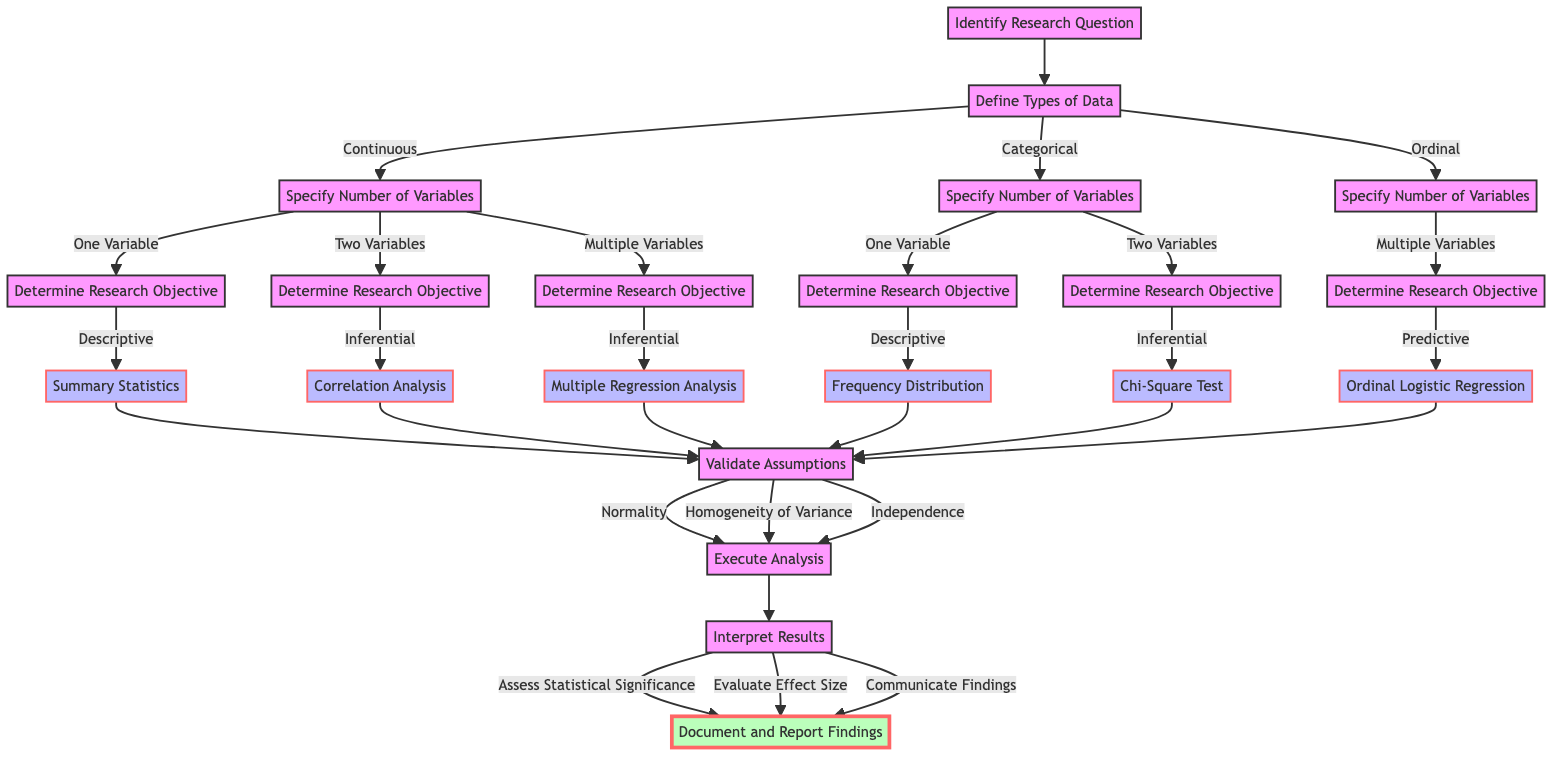What is the first step in the decision-making path? The diagram begins with the "Identify Research Question" node, indicating it is the starting point in the decision-making process for selecting a statistical analysis method.
Answer: Identify Research Question How many types of data are defined in the diagram? The diagram presents three types of data: Continuous, Categorical, and Ordinal, indicating that there are three specific categories to consider.
Answer: Three What method is selected for "Continuous and One Variable and Descriptive"? The condition results in the choice of "Summary Statistics (Mean, Median, SD)", which specifically caters to this scenario.
Answer: Summary Statistics (Mean, Median, SD) Which node follows "Validate Assumptions"? The next node after "Validate Assumptions" is "Execute Analysis", showing the progression from checking assumptions to executing the actual analysis.
Answer: Execute Analysis What is the significance of the edge that connects "Specify Number of Variables" to "Determine Research Objective"? This edge represents the decision point leading to selecting how many variables will be analyzed, impacting the objective, such as whether it is descriptive, inferential, or predictive.
Answer: It connects the number of variables to the research objective What assumptions must be validated according to the diagram? The diagram specifies three assumptions that must be validated: Normality, Homogeneity of Variance, and Independence, showcasing the essential checks needed before analysis.
Answer: Normality, Homogeneity of Variance, Independence What happens after the "Interpret Results" node? Following the "Interpret Results" node, it leads to the "Document and Report Findings" node, indicating the final step of the process where the results are formalized and shared.
Answer: Document and Report Findings If you are analyzing "Categorical and Two Variables and Inferential," which method would you select? The condition described leads to the method choice of "Chi-Square Test," which appropriately addresses the analysis of the categorical data with two variables in an inferential context.
Answer: Chi-Square Test In this diagram, how many paths lead to the "Execute Analysis" node? There are six distinct methods leading to the "Validate Assumptions" node, and each of those methods branches to the "Execute Analysis" node, indicating there are six paths in total.
Answer: Six 